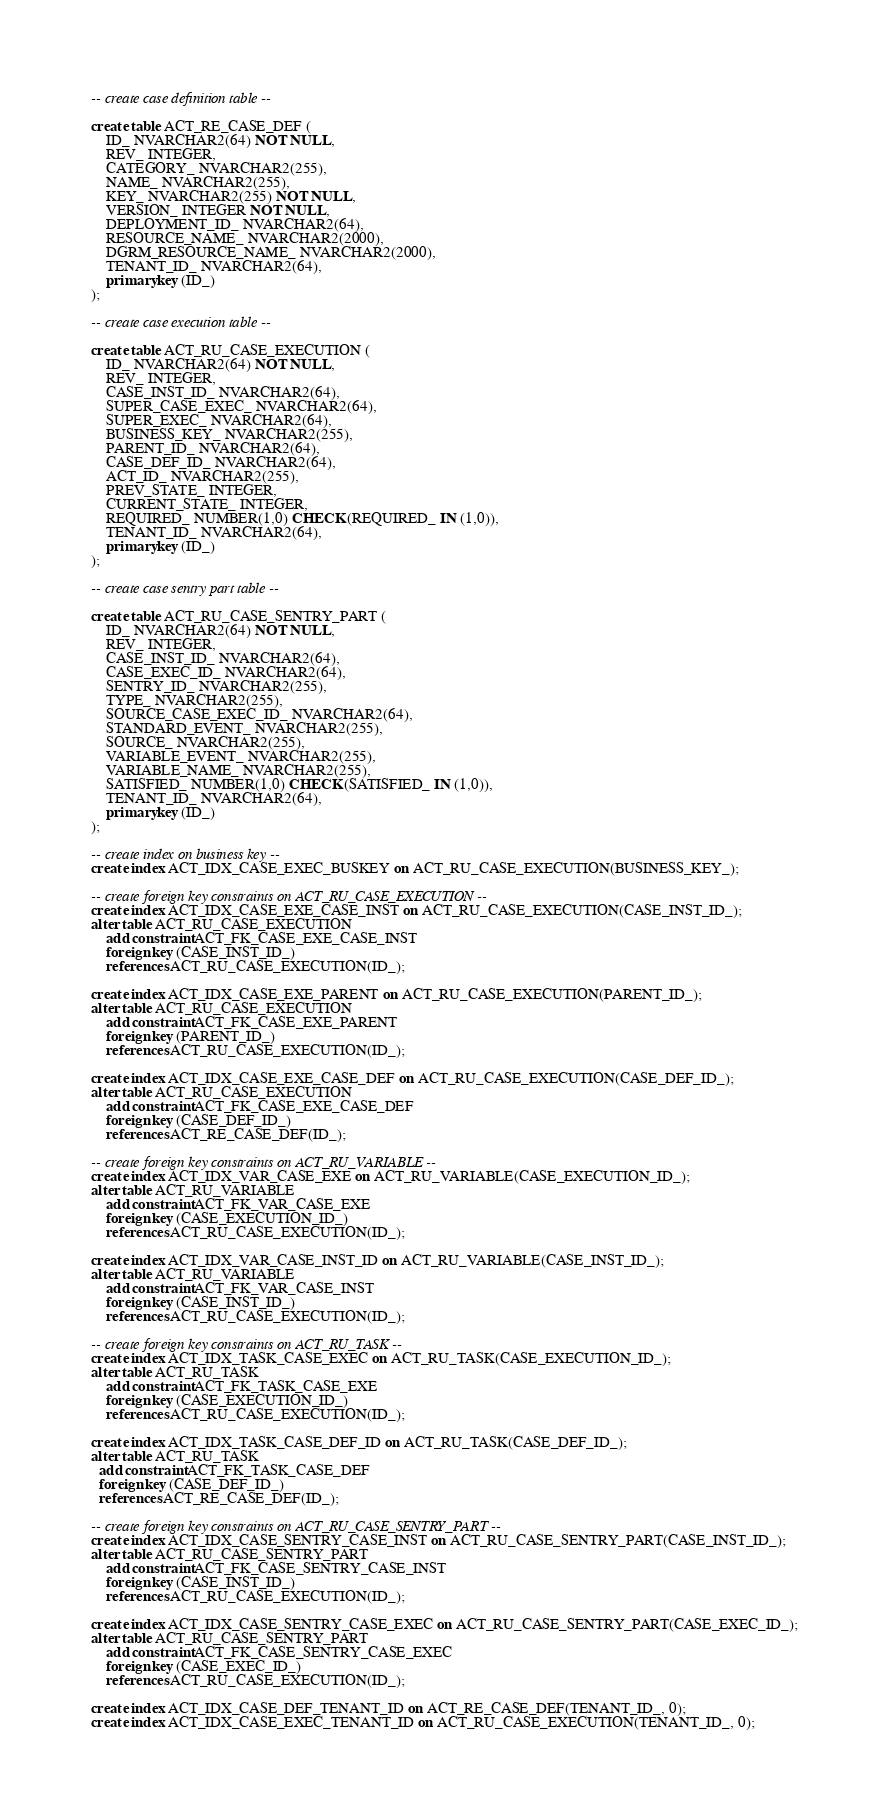Convert code to text. <code><loc_0><loc_0><loc_500><loc_500><_SQL_>-- create case definition table --

create table ACT_RE_CASE_DEF (
    ID_ NVARCHAR2(64) NOT NULL,
    REV_ INTEGER,
    CATEGORY_ NVARCHAR2(255),
    NAME_ NVARCHAR2(255),
    KEY_ NVARCHAR2(255) NOT NULL,
    VERSION_ INTEGER NOT NULL,
    DEPLOYMENT_ID_ NVARCHAR2(64),
    RESOURCE_NAME_ NVARCHAR2(2000),
    DGRM_RESOURCE_NAME_ NVARCHAR2(2000),
    TENANT_ID_ NVARCHAR2(64),
    primary key (ID_)
);

-- create case execution table --

create table ACT_RU_CASE_EXECUTION (
    ID_ NVARCHAR2(64) NOT NULL,
    REV_ INTEGER,
    CASE_INST_ID_ NVARCHAR2(64),
    SUPER_CASE_EXEC_ NVARCHAR2(64),
    SUPER_EXEC_ NVARCHAR2(64),
    BUSINESS_KEY_ NVARCHAR2(255),
    PARENT_ID_ NVARCHAR2(64),
    CASE_DEF_ID_ NVARCHAR2(64),
    ACT_ID_ NVARCHAR2(255),
    PREV_STATE_ INTEGER,
    CURRENT_STATE_ INTEGER,
    REQUIRED_ NUMBER(1,0) CHECK (REQUIRED_ IN (1,0)),
    TENANT_ID_ NVARCHAR2(64),
    primary key (ID_)
);

-- create case sentry part table --

create table ACT_RU_CASE_SENTRY_PART (
    ID_ NVARCHAR2(64) NOT NULL,
    REV_ INTEGER,
    CASE_INST_ID_ NVARCHAR2(64),
    CASE_EXEC_ID_ NVARCHAR2(64),
    SENTRY_ID_ NVARCHAR2(255),
    TYPE_ NVARCHAR2(255),
    SOURCE_CASE_EXEC_ID_ NVARCHAR2(64),
    STANDARD_EVENT_ NVARCHAR2(255),
    SOURCE_ NVARCHAR2(255),
    VARIABLE_EVENT_ NVARCHAR2(255),
    VARIABLE_NAME_ NVARCHAR2(255),
    SATISFIED_ NUMBER(1,0) CHECK (SATISFIED_ IN (1,0)),
    TENANT_ID_ NVARCHAR2(64),
    primary key (ID_)
);

-- create index on business key --
create index ACT_IDX_CASE_EXEC_BUSKEY on ACT_RU_CASE_EXECUTION(BUSINESS_KEY_);

-- create foreign key constraints on ACT_RU_CASE_EXECUTION --
create index ACT_IDX_CASE_EXE_CASE_INST on ACT_RU_CASE_EXECUTION(CASE_INST_ID_);
alter table ACT_RU_CASE_EXECUTION
    add constraint ACT_FK_CASE_EXE_CASE_INST
    foreign key (CASE_INST_ID_)
    references ACT_RU_CASE_EXECUTION(ID_);

create index ACT_IDX_CASE_EXE_PARENT on ACT_RU_CASE_EXECUTION(PARENT_ID_);
alter table ACT_RU_CASE_EXECUTION
    add constraint ACT_FK_CASE_EXE_PARENT
    foreign key (PARENT_ID_)
    references ACT_RU_CASE_EXECUTION(ID_);

create index ACT_IDX_CASE_EXE_CASE_DEF on ACT_RU_CASE_EXECUTION(CASE_DEF_ID_);
alter table ACT_RU_CASE_EXECUTION
    add constraint ACT_FK_CASE_EXE_CASE_DEF
    foreign key (CASE_DEF_ID_)
    references ACT_RE_CASE_DEF(ID_);

-- create foreign key constraints on ACT_RU_VARIABLE --
create index ACT_IDX_VAR_CASE_EXE on ACT_RU_VARIABLE(CASE_EXECUTION_ID_);
alter table ACT_RU_VARIABLE
    add constraint ACT_FK_VAR_CASE_EXE
    foreign key (CASE_EXECUTION_ID_)
    references ACT_RU_CASE_EXECUTION(ID_);

create index ACT_IDX_VAR_CASE_INST_ID on ACT_RU_VARIABLE(CASE_INST_ID_);
alter table ACT_RU_VARIABLE
    add constraint ACT_FK_VAR_CASE_INST
    foreign key (CASE_INST_ID_)
    references ACT_RU_CASE_EXECUTION(ID_);

-- create foreign key constraints on ACT_RU_TASK --
create index ACT_IDX_TASK_CASE_EXEC on ACT_RU_TASK(CASE_EXECUTION_ID_);
alter table ACT_RU_TASK
    add constraint ACT_FK_TASK_CASE_EXE
    foreign key (CASE_EXECUTION_ID_)
    references ACT_RU_CASE_EXECUTION(ID_);

create index ACT_IDX_TASK_CASE_DEF_ID on ACT_RU_TASK(CASE_DEF_ID_);
alter table ACT_RU_TASK
  add constraint ACT_FK_TASK_CASE_DEF
  foreign key (CASE_DEF_ID_)
  references ACT_RE_CASE_DEF(ID_);

-- create foreign key constraints on ACT_RU_CASE_SENTRY_PART --
create index ACT_IDX_CASE_SENTRY_CASE_INST on ACT_RU_CASE_SENTRY_PART(CASE_INST_ID_);
alter table ACT_RU_CASE_SENTRY_PART
    add constraint ACT_FK_CASE_SENTRY_CASE_INST
    foreign key (CASE_INST_ID_)
    references ACT_RU_CASE_EXECUTION(ID_);

create index ACT_IDX_CASE_SENTRY_CASE_EXEC on ACT_RU_CASE_SENTRY_PART(CASE_EXEC_ID_);
alter table ACT_RU_CASE_SENTRY_PART
    add constraint ACT_FK_CASE_SENTRY_CASE_EXEC
    foreign key (CASE_EXEC_ID_)
    references ACT_RU_CASE_EXECUTION(ID_);

create index ACT_IDX_CASE_DEF_TENANT_ID on ACT_RE_CASE_DEF(TENANT_ID_, 0);
create index ACT_IDX_CASE_EXEC_TENANT_ID on ACT_RU_CASE_EXECUTION(TENANT_ID_, 0);
</code> 